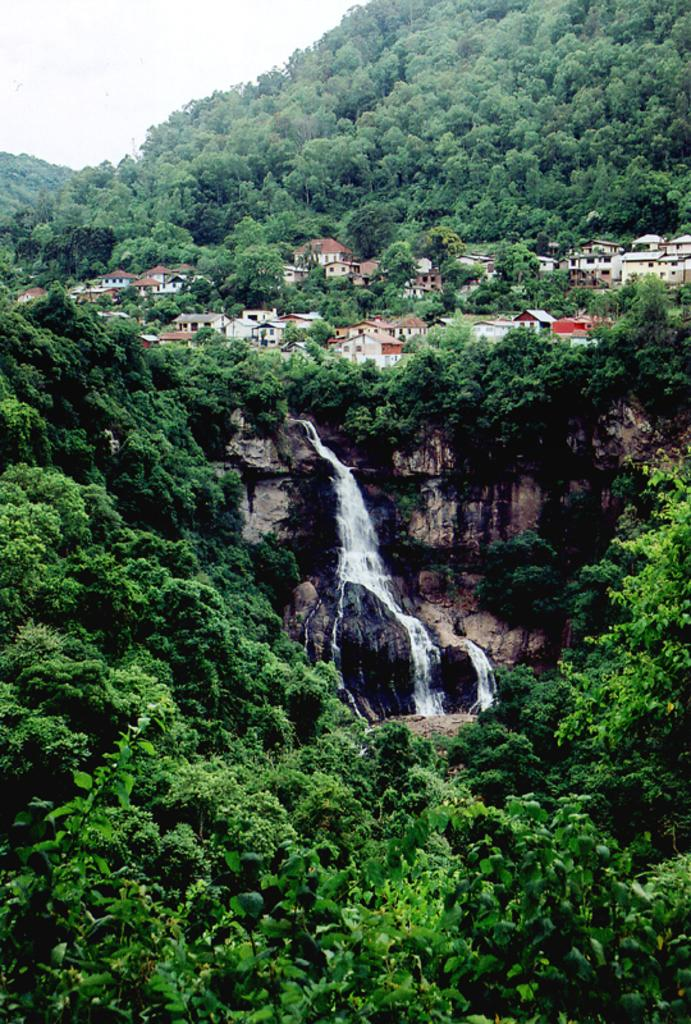What type of natural elements can be seen in the image? There are many trees and a waterfall in the image. What type of man-made structures are present in the image? There are buildings in the image. What can be seen in the background of the image? The sky is visible in the background of the image. What type of grape is growing on the mountain in the image? There is no mountain or grape present in the image. How does the waterfall make the viewer feel in the image? The image does not convey any feelings or emotions; it is a static representation of the scene. 